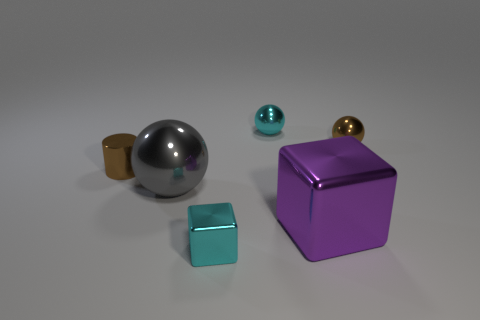Subtract 1 balls. How many balls are left? 2 Add 3 small metallic objects. How many objects exist? 9 Subtract all tiny metal spheres. How many spheres are left? 1 Subtract all cubes. How many objects are left? 4 Subtract all gray balls. Subtract all brown things. How many objects are left? 3 Add 1 purple metallic blocks. How many purple metallic blocks are left? 2 Add 1 yellow things. How many yellow things exist? 1 Subtract 0 blue balls. How many objects are left? 6 Subtract all yellow balls. Subtract all red cylinders. How many balls are left? 3 